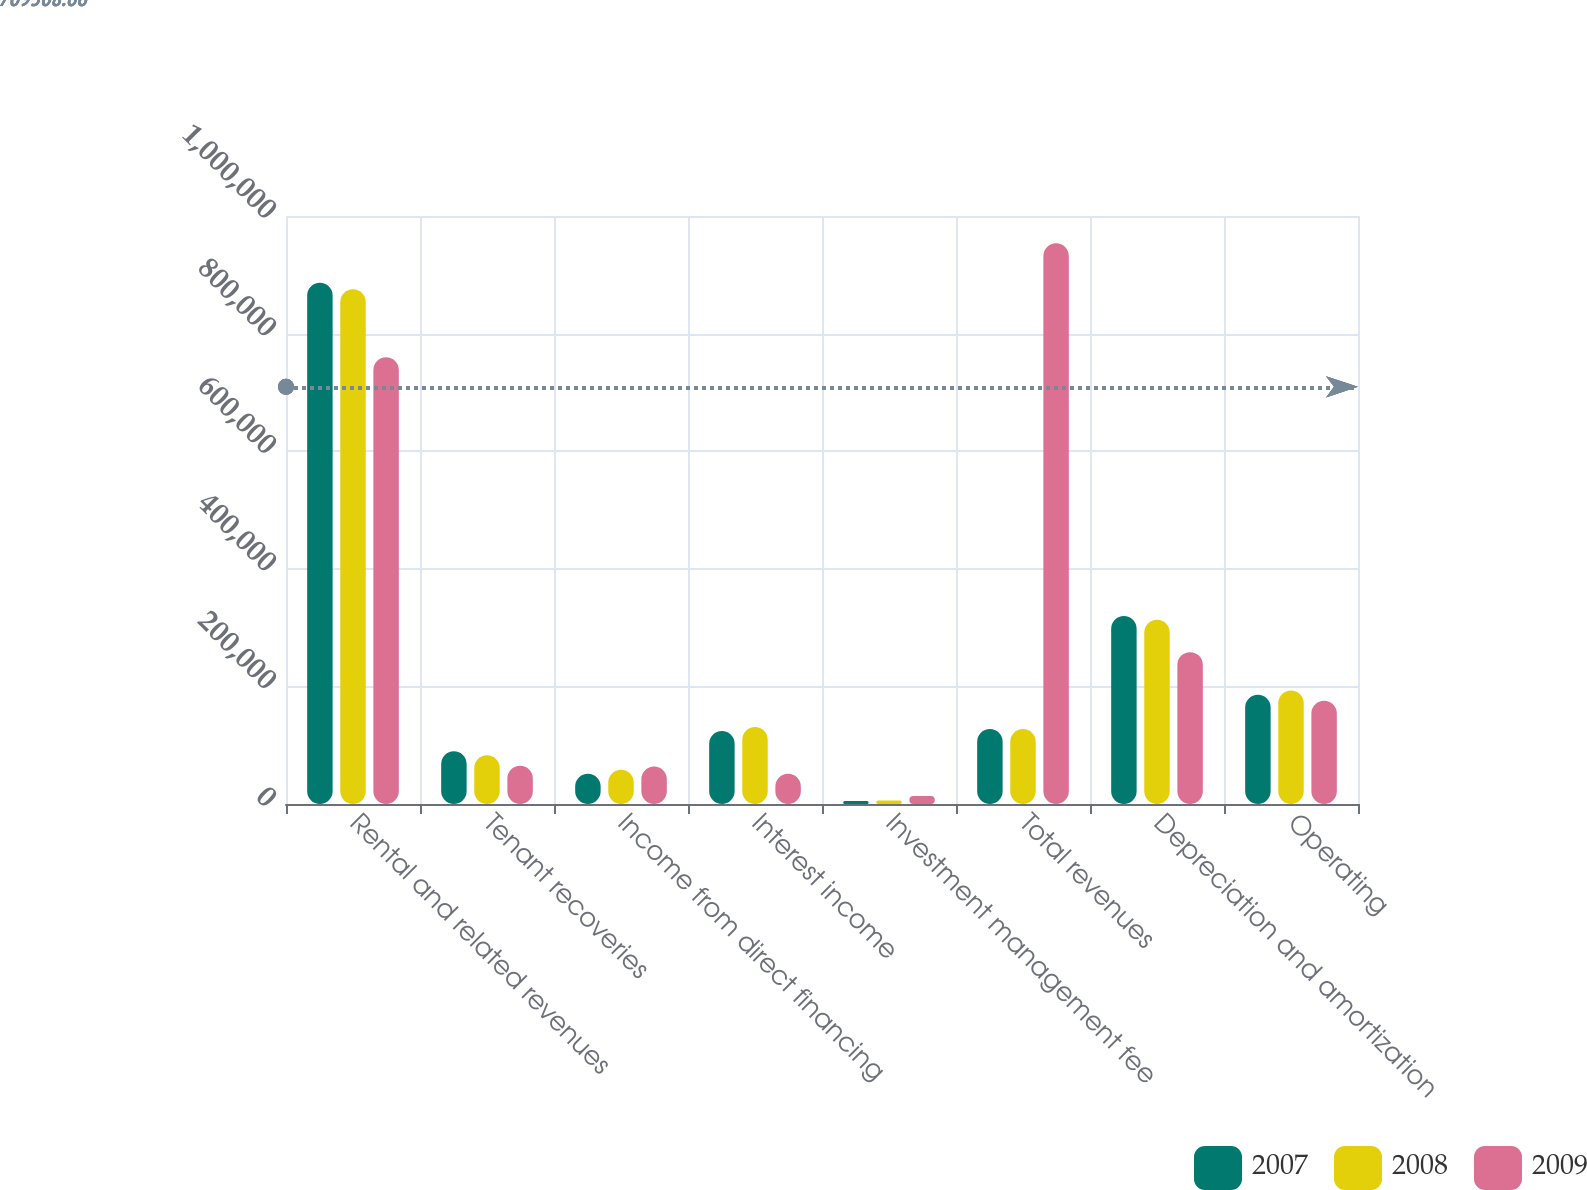Convert chart to OTSL. <chart><loc_0><loc_0><loc_500><loc_500><stacked_bar_chart><ecel><fcel>Rental and related revenues<fcel>Tenant recoveries<fcel>Income from direct financing<fcel>Interest income<fcel>Investment management fee<fcel>Total revenues<fcel>Depreciation and amortization<fcel>Operating<nl><fcel>2007<fcel>886495<fcel>89582<fcel>51495<fcel>124146<fcel>5312<fcel>127508<fcel>319583<fcel>185898<nl><fcel>2008<fcel>875436<fcel>82811<fcel>58149<fcel>130869<fcel>5923<fcel>127508<fcel>313404<fcel>193121<nl><fcel>2009<fcel>759813<fcel>64932<fcel>63852<fcel>51565<fcel>13581<fcel>953743<fcel>258264<fcel>175704<nl></chart> 